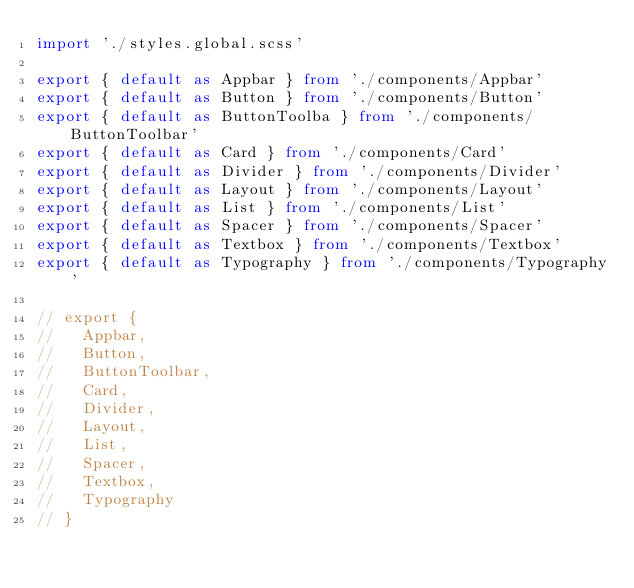Convert code to text. <code><loc_0><loc_0><loc_500><loc_500><_TypeScript_>import './styles.global.scss'

export { default as Appbar } from './components/Appbar'
export { default as Button } from './components/Button'
export { default as ButtonToolba } from './components/ButtonToolbar'
export { default as Card } from './components/Card'
export { default as Divider } from './components/Divider'
export { default as Layout } from './components/Layout'
export { default as List } from './components/List'
export { default as Spacer } from './components/Spacer'
export { default as Textbox } from './components/Textbox'
export { default as Typography } from './components/Typography'

// export {
//   Appbar,
//   Button,
//   ButtonToolbar,
//   Card,
//   Divider,
//   Layout,
//   List,
//   Spacer,
//   Textbox,
//   Typography
// }
</code> 